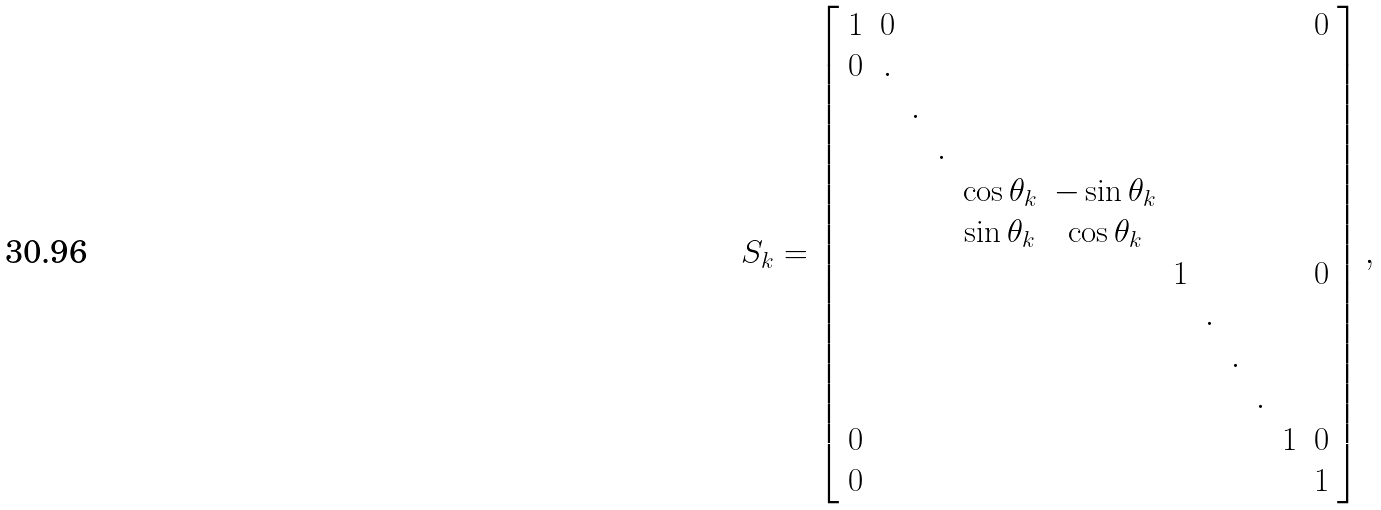<formula> <loc_0><loc_0><loc_500><loc_500>S _ { k } = \left [ \begin{array} { c c c c c c c c c c c c } 1 & 0 & & & & & & & & & & 0 \\ 0 & . & & & & & & & & & & \\ & & . & & & & & & & & & \\ & & & . & & & & & & & & \\ & & & & \cos \theta _ { k } & - \sin \theta _ { k } & & & & & & \\ & & & & \sin \theta _ { k } & \cos \theta _ { k } & & & & & & \\ & & & & & & 1 & & & & & 0 \\ & & & & & & & . & & & & \\ & & & & & & & & . & & & \\ & & & & & & & & & . & & \\ 0 & & & & & & & & & & 1 & 0 \\ 0 & & & & & & & & & & & 1 \\ \end{array} \right ] ,</formula> 